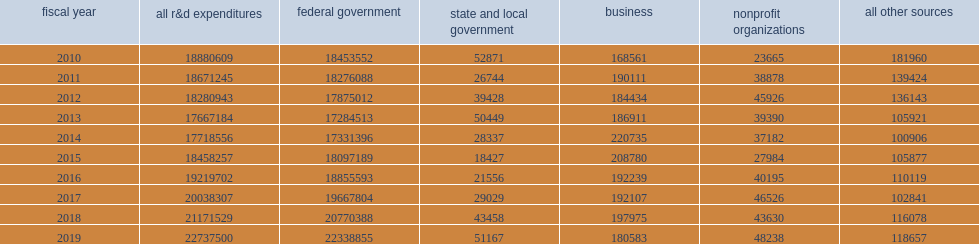How many thousand dollars did the nation's 42 federally funded research and development centers (ffrdcs) spend on research and development in fy 2019? 22737500.0. How many thousand dollars did the federal government's share of support reach in fy 2019? 22338855.0. 